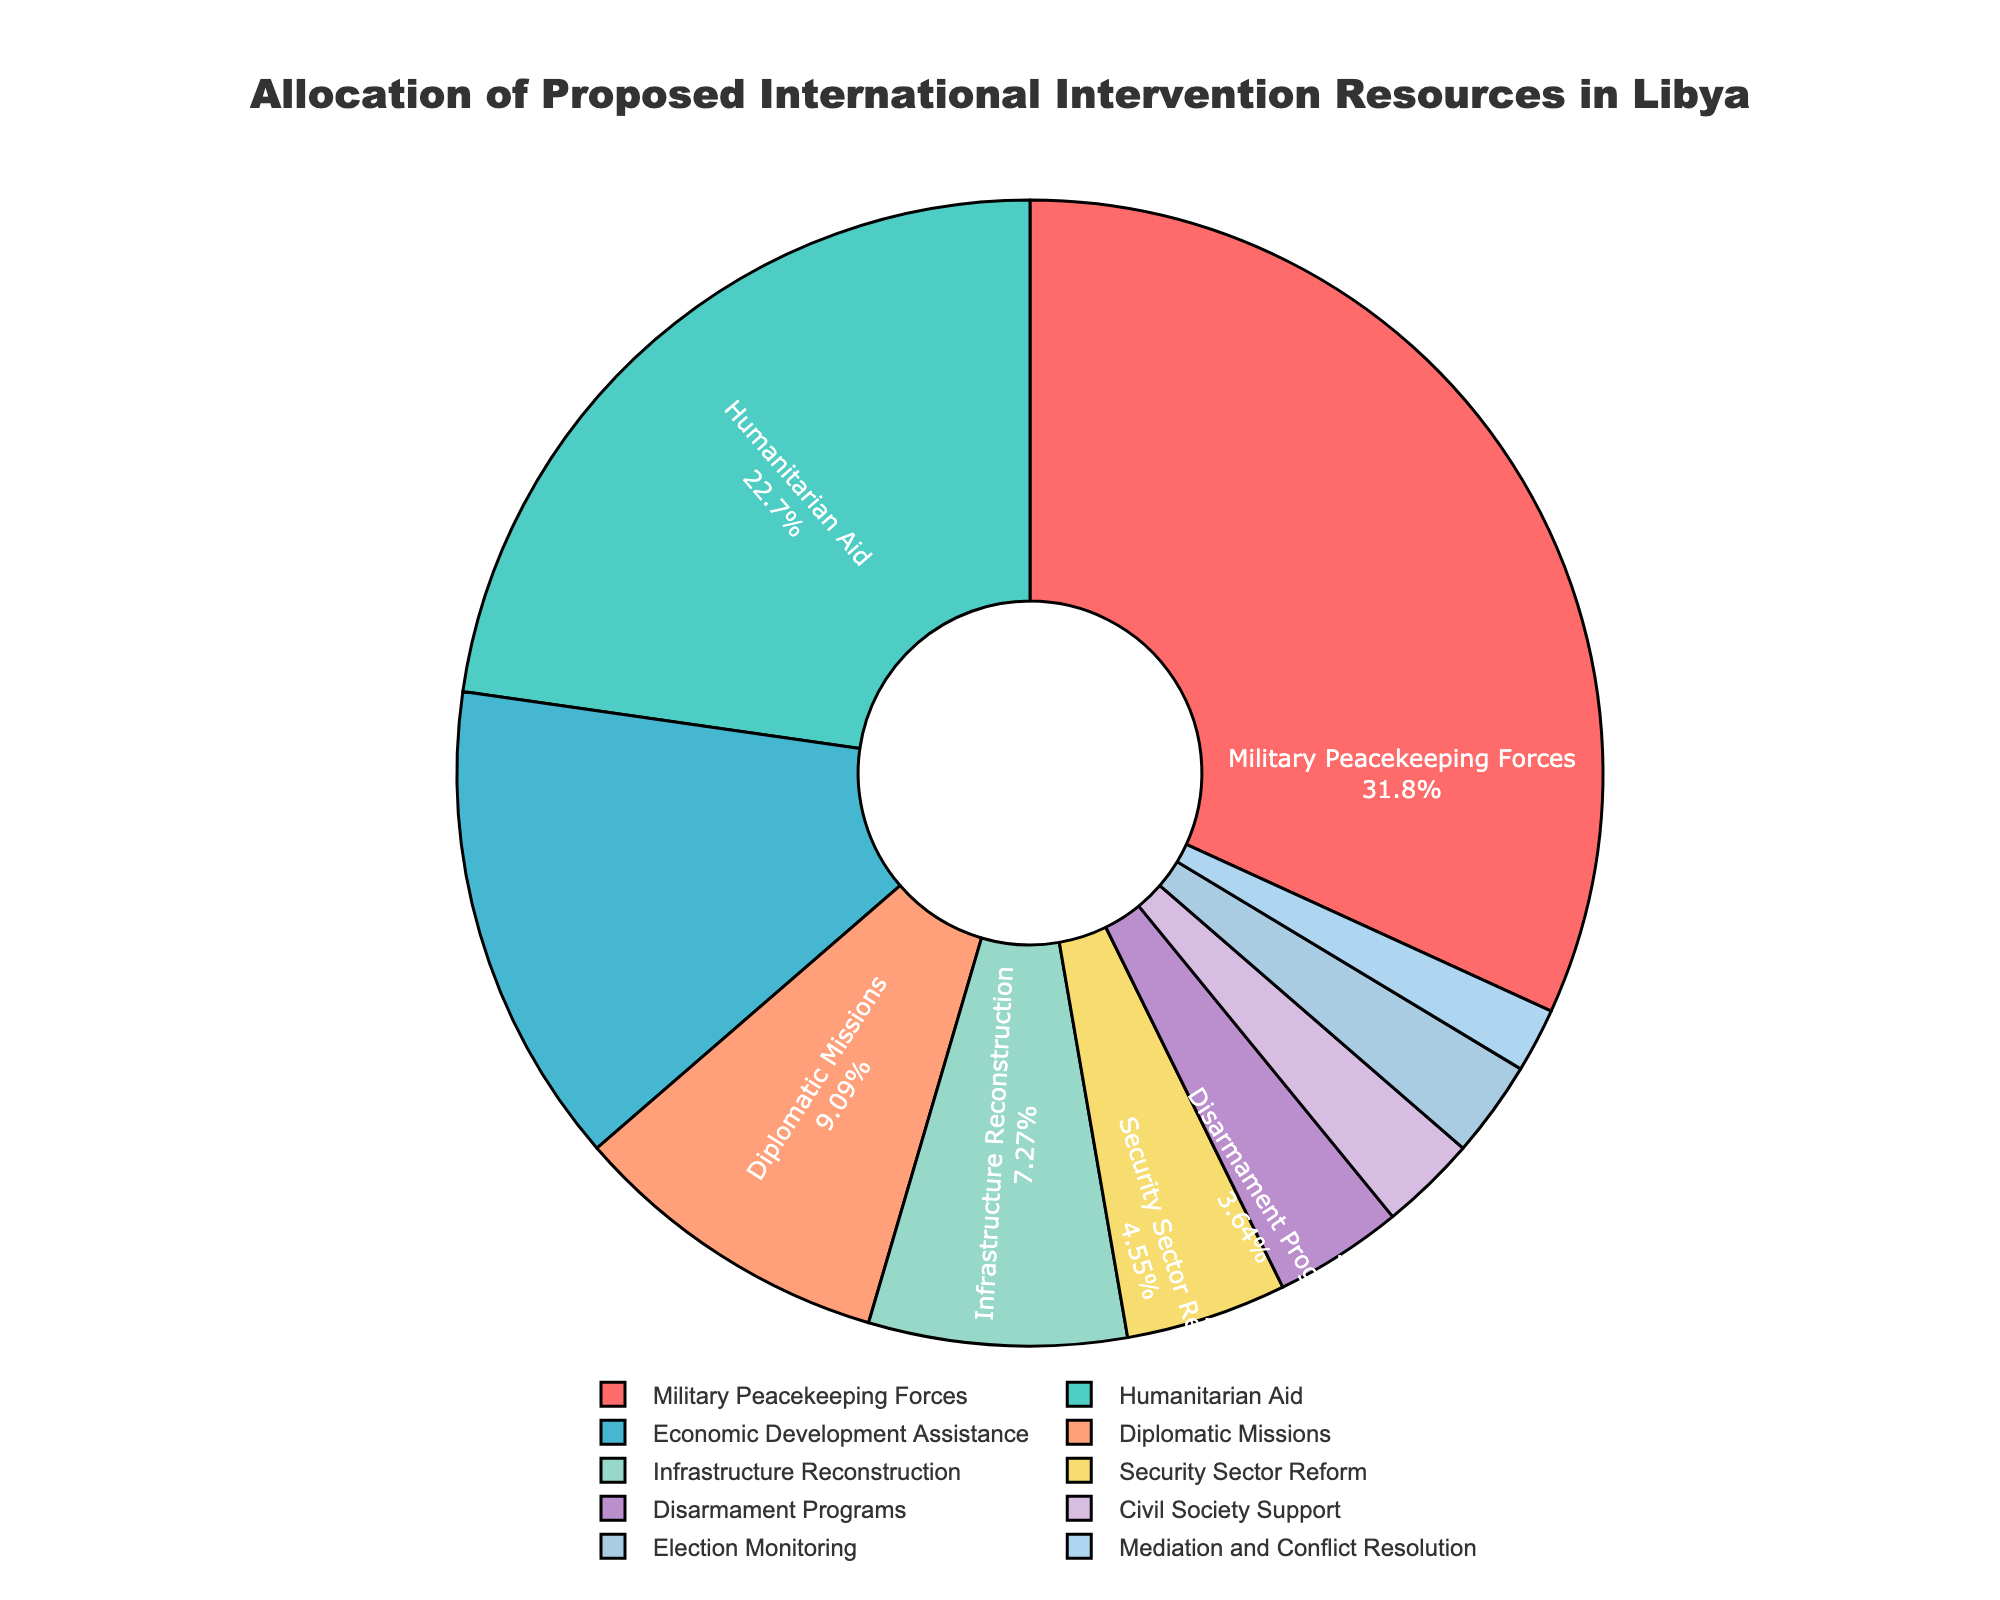Which resource has the highest allocation? Look at the figure and identify the resource with the largest percentage segment. The Military Peacekeeping Forces segment is the largest.
Answer: Military Peacekeeping Forces What is the combined allocation for Humanitarian Aid and Economic Development Assistance? Add the percentages of Humanitarian Aid and Economic Development Assistance. Humanitarian Aid is 25% and Economic Development Assistance is 15%. 25 + 15 = 40
Answer: 40% How much greater is the allocation for Military Peacekeeping Forces compared to Security Sector Reform? Subtract the percentage of Security Sector Reform from Military Peacekeeping Forces. Military Peacekeeping Forces is 35%, and Security Sector Reform is 5%. 35 - 5 = 30
Answer: 30% Which three resources have the smallest allocation, and what is the total allocation for those three? Identify the three smallest segments and add their percentages. They are Mediation and Conflict Resolution (2%), Civil Society Support (3%), and Election Monitoring (3%). 2 + 3 + 3 = 8
Answer: Mediation and Conflict Resolution, Civil Society Support, Election Monitoring; 8% Is the allocation for Economic Development Assistance greater than for Diplomatic Missions? Compare the percentages of Economic Development Assistance and Diplomatic Missions. Economic Development Assistance is 15%, while Diplomatic Missions is 10%. 15 is greater than 10.
Answer: Yes What percentage of resources is allocated to sectors related to security (Military Peacekeeping Forces, Security Sector Reform, Disarmament Programs)? Add the percentages of Military Peacekeeping Forces, Security Sector Reform, and Disarmament Programs. Military Peacekeeping Forces is 35%, Security Sector Reform is 5%, and Disarmament Programs is 4%. 35 + 5 + 4 = 44
Answer: 44% Which segment is represented by a shade of green and what is its percentage? Identify the green-colored segment. Humanitarian Aid is represented by a shade of green at 25%.
Answer: Humanitarian Aid; 25% 